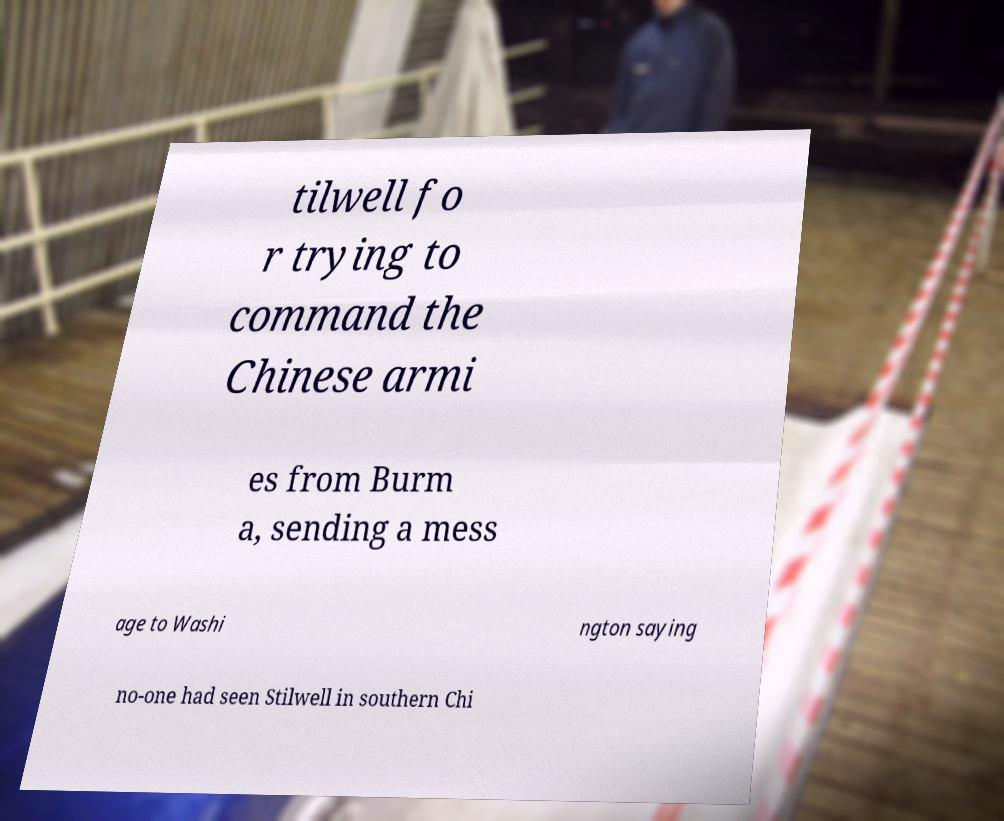I need the written content from this picture converted into text. Can you do that? tilwell fo r trying to command the Chinese armi es from Burm a, sending a mess age to Washi ngton saying no-one had seen Stilwell in southern Chi 